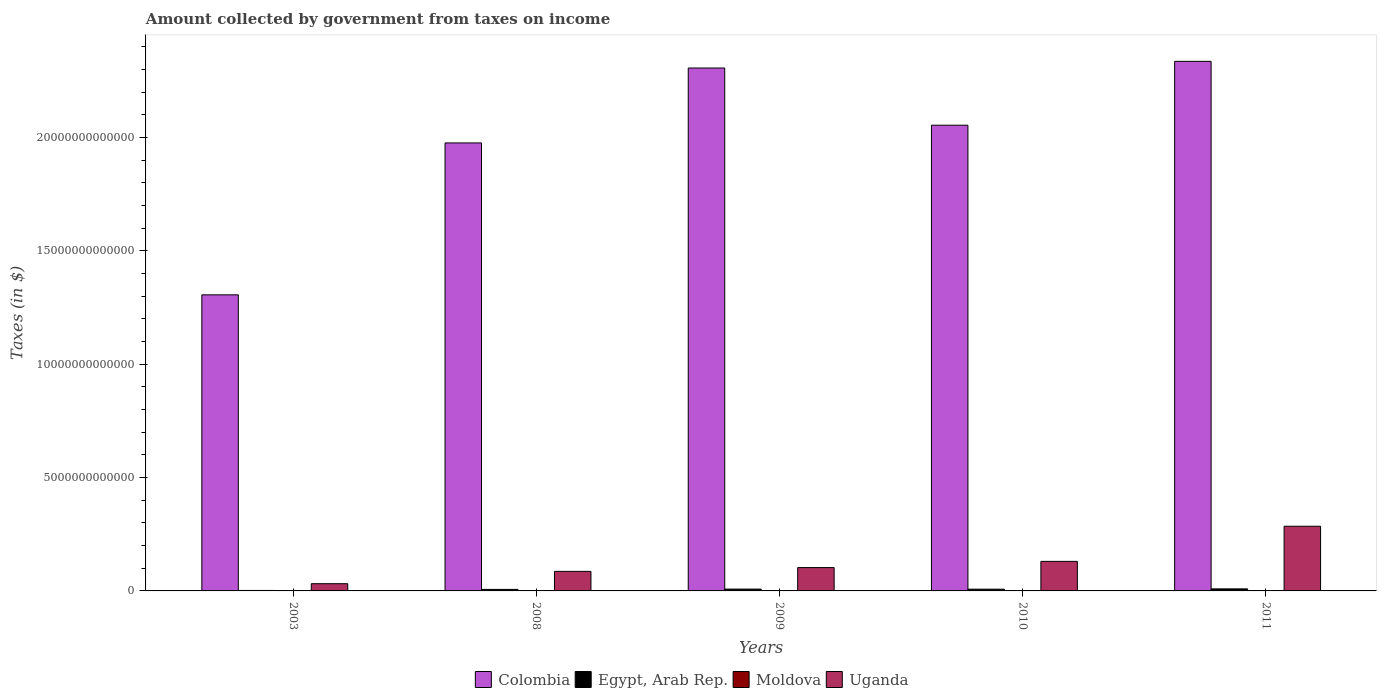How many groups of bars are there?
Offer a very short reply. 5. Are the number of bars per tick equal to the number of legend labels?
Offer a very short reply. Yes. Are the number of bars on each tick of the X-axis equal?
Provide a succinct answer. Yes. How many bars are there on the 5th tick from the left?
Your answer should be very brief. 4. How many bars are there on the 4th tick from the right?
Ensure brevity in your answer.  4. What is the label of the 3rd group of bars from the left?
Offer a very short reply. 2009. In how many cases, is the number of bars for a given year not equal to the number of legend labels?
Offer a terse response. 0. What is the amount collected by government from taxes on income in Moldova in 2009?
Make the answer very short. 1.83e+08. Across all years, what is the maximum amount collected by government from taxes on income in Uganda?
Give a very brief answer. 2.85e+12. Across all years, what is the minimum amount collected by government from taxes on income in Moldova?
Your answer should be compact. 1.83e+08. In which year was the amount collected by government from taxes on income in Egypt, Arab Rep. minimum?
Keep it short and to the point. 2003. What is the total amount collected by government from taxes on income in Moldova in the graph?
Offer a terse response. 1.17e+09. What is the difference between the amount collected by government from taxes on income in Egypt, Arab Rep. in 2003 and that in 2011?
Make the answer very short. -6.88e+1. What is the difference between the amount collected by government from taxes on income in Moldova in 2010 and the amount collected by government from taxes on income in Colombia in 2009?
Make the answer very short. -2.31e+13. What is the average amount collected by government from taxes on income in Moldova per year?
Offer a very short reply. 2.34e+08. In the year 2011, what is the difference between the amount collected by government from taxes on income in Uganda and amount collected by government from taxes on income in Moldova?
Make the answer very short. 2.85e+12. What is the ratio of the amount collected by government from taxes on income in Uganda in 2008 to that in 2009?
Your answer should be compact. 0.84. Is the amount collected by government from taxes on income in Uganda in 2008 less than that in 2009?
Ensure brevity in your answer.  Yes. Is the difference between the amount collected by government from taxes on income in Uganda in 2003 and 2011 greater than the difference between the amount collected by government from taxes on income in Moldova in 2003 and 2011?
Provide a succinct answer. No. What is the difference between the highest and the second highest amount collected by government from taxes on income in Egypt, Arab Rep.?
Offer a terse response. 9.34e+09. What is the difference between the highest and the lowest amount collected by government from taxes on income in Moldova?
Provide a succinct answer. 1.20e+08. What does the 3rd bar from the right in 2011 represents?
Ensure brevity in your answer.  Egypt, Arab Rep. Is it the case that in every year, the sum of the amount collected by government from taxes on income in Egypt, Arab Rep. and amount collected by government from taxes on income in Colombia is greater than the amount collected by government from taxes on income in Uganda?
Ensure brevity in your answer.  Yes. How many bars are there?
Offer a very short reply. 20. Are all the bars in the graph horizontal?
Give a very brief answer. No. What is the difference between two consecutive major ticks on the Y-axis?
Offer a very short reply. 5.00e+12. Are the values on the major ticks of Y-axis written in scientific E-notation?
Ensure brevity in your answer.  No. Does the graph contain any zero values?
Your response must be concise. No. Where does the legend appear in the graph?
Make the answer very short. Bottom center. How many legend labels are there?
Give a very brief answer. 4. How are the legend labels stacked?
Provide a succinct answer. Horizontal. What is the title of the graph?
Provide a short and direct response. Amount collected by government from taxes on income. What is the label or title of the Y-axis?
Give a very brief answer. Taxes (in $). What is the Taxes (in $) in Colombia in 2003?
Make the answer very short. 1.31e+13. What is the Taxes (in $) in Egypt, Arab Rep. in 2003?
Make the answer very short. 2.08e+1. What is the Taxes (in $) of Moldova in 2003?
Your answer should be compact. 2.12e+08. What is the Taxes (in $) of Uganda in 2003?
Your answer should be compact. 3.19e+11. What is the Taxes (in $) in Colombia in 2008?
Keep it short and to the point. 1.98e+13. What is the Taxes (in $) in Egypt, Arab Rep. in 2008?
Make the answer very short. 6.71e+1. What is the Taxes (in $) of Moldova in 2008?
Provide a succinct answer. 3.03e+08. What is the Taxes (in $) in Uganda in 2008?
Your answer should be compact. 8.62e+11. What is the Taxes (in $) in Colombia in 2009?
Ensure brevity in your answer.  2.31e+13. What is the Taxes (in $) in Egypt, Arab Rep. in 2009?
Provide a short and direct response. 8.03e+1. What is the Taxes (in $) of Moldova in 2009?
Keep it short and to the point. 1.83e+08. What is the Taxes (in $) in Uganda in 2009?
Offer a very short reply. 1.03e+12. What is the Taxes (in $) in Colombia in 2010?
Your answer should be very brief. 2.05e+13. What is the Taxes (in $) in Egypt, Arab Rep. in 2010?
Offer a terse response. 7.66e+1. What is the Taxes (in $) in Moldova in 2010?
Provide a short and direct response. 2.16e+08. What is the Taxes (in $) in Uganda in 2010?
Ensure brevity in your answer.  1.30e+12. What is the Taxes (in $) in Colombia in 2011?
Your answer should be compact. 2.34e+13. What is the Taxes (in $) of Egypt, Arab Rep. in 2011?
Keep it short and to the point. 8.96e+1. What is the Taxes (in $) in Moldova in 2011?
Ensure brevity in your answer.  2.58e+08. What is the Taxes (in $) in Uganda in 2011?
Keep it short and to the point. 2.85e+12. Across all years, what is the maximum Taxes (in $) in Colombia?
Ensure brevity in your answer.  2.34e+13. Across all years, what is the maximum Taxes (in $) of Egypt, Arab Rep.?
Ensure brevity in your answer.  8.96e+1. Across all years, what is the maximum Taxes (in $) in Moldova?
Your answer should be very brief. 3.03e+08. Across all years, what is the maximum Taxes (in $) of Uganda?
Your answer should be very brief. 2.85e+12. Across all years, what is the minimum Taxes (in $) of Colombia?
Your response must be concise. 1.31e+13. Across all years, what is the minimum Taxes (in $) of Egypt, Arab Rep.?
Give a very brief answer. 2.08e+1. Across all years, what is the minimum Taxes (in $) in Moldova?
Offer a terse response. 1.83e+08. Across all years, what is the minimum Taxes (in $) of Uganda?
Your answer should be very brief. 3.19e+11. What is the total Taxes (in $) in Colombia in the graph?
Your answer should be very brief. 9.98e+13. What is the total Taxes (in $) of Egypt, Arab Rep. in the graph?
Ensure brevity in your answer.  3.34e+11. What is the total Taxes (in $) of Moldova in the graph?
Offer a terse response. 1.17e+09. What is the total Taxes (in $) in Uganda in the graph?
Ensure brevity in your answer.  6.37e+12. What is the difference between the Taxes (in $) in Colombia in 2003 and that in 2008?
Your answer should be very brief. -6.70e+12. What is the difference between the Taxes (in $) of Egypt, Arab Rep. in 2003 and that in 2008?
Your answer should be compact. -4.62e+1. What is the difference between the Taxes (in $) in Moldova in 2003 and that in 2008?
Keep it short and to the point. -9.14e+07. What is the difference between the Taxes (in $) in Uganda in 2003 and that in 2008?
Offer a terse response. -5.43e+11. What is the difference between the Taxes (in $) of Colombia in 2003 and that in 2009?
Your response must be concise. -1.00e+13. What is the difference between the Taxes (in $) in Egypt, Arab Rep. in 2003 and that in 2009?
Keep it short and to the point. -5.94e+1. What is the difference between the Taxes (in $) of Moldova in 2003 and that in 2009?
Your response must be concise. 2.87e+07. What is the difference between the Taxes (in $) in Uganda in 2003 and that in 2009?
Offer a very short reply. -7.10e+11. What is the difference between the Taxes (in $) in Colombia in 2003 and that in 2010?
Keep it short and to the point. -7.48e+12. What is the difference between the Taxes (in $) in Egypt, Arab Rep. in 2003 and that in 2010?
Offer a terse response. -5.58e+1. What is the difference between the Taxes (in $) of Moldova in 2003 and that in 2010?
Offer a terse response. -3.80e+06. What is the difference between the Taxes (in $) of Uganda in 2003 and that in 2010?
Offer a terse response. -9.84e+11. What is the difference between the Taxes (in $) of Colombia in 2003 and that in 2011?
Offer a very short reply. -1.03e+13. What is the difference between the Taxes (in $) of Egypt, Arab Rep. in 2003 and that in 2011?
Offer a terse response. -6.88e+1. What is the difference between the Taxes (in $) of Moldova in 2003 and that in 2011?
Provide a short and direct response. -4.66e+07. What is the difference between the Taxes (in $) in Uganda in 2003 and that in 2011?
Give a very brief answer. -2.53e+12. What is the difference between the Taxes (in $) of Colombia in 2008 and that in 2009?
Your answer should be compact. -3.30e+12. What is the difference between the Taxes (in $) in Egypt, Arab Rep. in 2008 and that in 2009?
Your answer should be very brief. -1.32e+1. What is the difference between the Taxes (in $) in Moldova in 2008 and that in 2009?
Your response must be concise. 1.20e+08. What is the difference between the Taxes (in $) of Uganda in 2008 and that in 2009?
Your answer should be compact. -1.67e+11. What is the difference between the Taxes (in $) in Colombia in 2008 and that in 2010?
Your response must be concise. -7.82e+11. What is the difference between the Taxes (in $) in Egypt, Arab Rep. in 2008 and that in 2010?
Provide a succinct answer. -9.56e+09. What is the difference between the Taxes (in $) in Moldova in 2008 and that in 2010?
Provide a succinct answer. 8.76e+07. What is the difference between the Taxes (in $) of Uganda in 2008 and that in 2010?
Make the answer very short. -4.41e+11. What is the difference between the Taxes (in $) of Colombia in 2008 and that in 2011?
Offer a very short reply. -3.60e+12. What is the difference between the Taxes (in $) of Egypt, Arab Rep. in 2008 and that in 2011?
Your answer should be compact. -2.25e+1. What is the difference between the Taxes (in $) in Moldova in 2008 and that in 2011?
Ensure brevity in your answer.  4.48e+07. What is the difference between the Taxes (in $) of Uganda in 2008 and that in 2011?
Your response must be concise. -1.99e+12. What is the difference between the Taxes (in $) in Colombia in 2009 and that in 2010?
Your answer should be compact. 2.52e+12. What is the difference between the Taxes (in $) in Egypt, Arab Rep. in 2009 and that in 2010?
Your response must be concise. 3.64e+09. What is the difference between the Taxes (in $) of Moldova in 2009 and that in 2010?
Provide a succinct answer. -3.25e+07. What is the difference between the Taxes (in $) of Uganda in 2009 and that in 2010?
Make the answer very short. -2.74e+11. What is the difference between the Taxes (in $) of Colombia in 2009 and that in 2011?
Your answer should be compact. -2.94e+11. What is the difference between the Taxes (in $) of Egypt, Arab Rep. in 2009 and that in 2011?
Give a very brief answer. -9.34e+09. What is the difference between the Taxes (in $) of Moldova in 2009 and that in 2011?
Offer a terse response. -7.53e+07. What is the difference between the Taxes (in $) in Uganda in 2009 and that in 2011?
Ensure brevity in your answer.  -1.82e+12. What is the difference between the Taxes (in $) in Colombia in 2010 and that in 2011?
Offer a terse response. -2.82e+12. What is the difference between the Taxes (in $) of Egypt, Arab Rep. in 2010 and that in 2011?
Offer a terse response. -1.30e+1. What is the difference between the Taxes (in $) in Moldova in 2010 and that in 2011?
Provide a succinct answer. -4.28e+07. What is the difference between the Taxes (in $) of Uganda in 2010 and that in 2011?
Give a very brief answer. -1.55e+12. What is the difference between the Taxes (in $) of Colombia in 2003 and the Taxes (in $) of Egypt, Arab Rep. in 2008?
Ensure brevity in your answer.  1.30e+13. What is the difference between the Taxes (in $) in Colombia in 2003 and the Taxes (in $) in Moldova in 2008?
Keep it short and to the point. 1.31e+13. What is the difference between the Taxes (in $) of Colombia in 2003 and the Taxes (in $) of Uganda in 2008?
Offer a terse response. 1.22e+13. What is the difference between the Taxes (in $) in Egypt, Arab Rep. in 2003 and the Taxes (in $) in Moldova in 2008?
Ensure brevity in your answer.  2.05e+1. What is the difference between the Taxes (in $) of Egypt, Arab Rep. in 2003 and the Taxes (in $) of Uganda in 2008?
Offer a very short reply. -8.41e+11. What is the difference between the Taxes (in $) of Moldova in 2003 and the Taxes (in $) of Uganda in 2008?
Give a very brief answer. -8.62e+11. What is the difference between the Taxes (in $) of Colombia in 2003 and the Taxes (in $) of Egypt, Arab Rep. in 2009?
Ensure brevity in your answer.  1.30e+13. What is the difference between the Taxes (in $) in Colombia in 2003 and the Taxes (in $) in Moldova in 2009?
Provide a succinct answer. 1.31e+13. What is the difference between the Taxes (in $) of Colombia in 2003 and the Taxes (in $) of Uganda in 2009?
Give a very brief answer. 1.20e+13. What is the difference between the Taxes (in $) of Egypt, Arab Rep. in 2003 and the Taxes (in $) of Moldova in 2009?
Keep it short and to the point. 2.07e+1. What is the difference between the Taxes (in $) of Egypt, Arab Rep. in 2003 and the Taxes (in $) of Uganda in 2009?
Give a very brief answer. -1.01e+12. What is the difference between the Taxes (in $) in Moldova in 2003 and the Taxes (in $) in Uganda in 2009?
Your answer should be very brief. -1.03e+12. What is the difference between the Taxes (in $) of Colombia in 2003 and the Taxes (in $) of Egypt, Arab Rep. in 2010?
Give a very brief answer. 1.30e+13. What is the difference between the Taxes (in $) of Colombia in 2003 and the Taxes (in $) of Moldova in 2010?
Keep it short and to the point. 1.31e+13. What is the difference between the Taxes (in $) of Colombia in 2003 and the Taxes (in $) of Uganda in 2010?
Provide a succinct answer. 1.18e+13. What is the difference between the Taxes (in $) of Egypt, Arab Rep. in 2003 and the Taxes (in $) of Moldova in 2010?
Give a very brief answer. 2.06e+1. What is the difference between the Taxes (in $) of Egypt, Arab Rep. in 2003 and the Taxes (in $) of Uganda in 2010?
Give a very brief answer. -1.28e+12. What is the difference between the Taxes (in $) of Moldova in 2003 and the Taxes (in $) of Uganda in 2010?
Keep it short and to the point. -1.30e+12. What is the difference between the Taxes (in $) in Colombia in 2003 and the Taxes (in $) in Egypt, Arab Rep. in 2011?
Offer a terse response. 1.30e+13. What is the difference between the Taxes (in $) of Colombia in 2003 and the Taxes (in $) of Moldova in 2011?
Your answer should be very brief. 1.31e+13. What is the difference between the Taxes (in $) of Colombia in 2003 and the Taxes (in $) of Uganda in 2011?
Your answer should be very brief. 1.02e+13. What is the difference between the Taxes (in $) in Egypt, Arab Rep. in 2003 and the Taxes (in $) in Moldova in 2011?
Your answer should be very brief. 2.06e+1. What is the difference between the Taxes (in $) of Egypt, Arab Rep. in 2003 and the Taxes (in $) of Uganda in 2011?
Offer a terse response. -2.83e+12. What is the difference between the Taxes (in $) of Moldova in 2003 and the Taxes (in $) of Uganda in 2011?
Make the answer very short. -2.85e+12. What is the difference between the Taxes (in $) of Colombia in 2008 and the Taxes (in $) of Egypt, Arab Rep. in 2009?
Keep it short and to the point. 1.97e+13. What is the difference between the Taxes (in $) of Colombia in 2008 and the Taxes (in $) of Moldova in 2009?
Your answer should be compact. 1.98e+13. What is the difference between the Taxes (in $) in Colombia in 2008 and the Taxes (in $) in Uganda in 2009?
Your answer should be very brief. 1.87e+13. What is the difference between the Taxes (in $) in Egypt, Arab Rep. in 2008 and the Taxes (in $) in Moldova in 2009?
Offer a terse response. 6.69e+1. What is the difference between the Taxes (in $) of Egypt, Arab Rep. in 2008 and the Taxes (in $) of Uganda in 2009?
Provide a short and direct response. -9.62e+11. What is the difference between the Taxes (in $) in Moldova in 2008 and the Taxes (in $) in Uganda in 2009?
Ensure brevity in your answer.  -1.03e+12. What is the difference between the Taxes (in $) in Colombia in 2008 and the Taxes (in $) in Egypt, Arab Rep. in 2010?
Ensure brevity in your answer.  1.97e+13. What is the difference between the Taxes (in $) of Colombia in 2008 and the Taxes (in $) of Moldova in 2010?
Offer a terse response. 1.98e+13. What is the difference between the Taxes (in $) of Colombia in 2008 and the Taxes (in $) of Uganda in 2010?
Make the answer very short. 1.85e+13. What is the difference between the Taxes (in $) in Egypt, Arab Rep. in 2008 and the Taxes (in $) in Moldova in 2010?
Offer a very short reply. 6.68e+1. What is the difference between the Taxes (in $) of Egypt, Arab Rep. in 2008 and the Taxes (in $) of Uganda in 2010?
Provide a succinct answer. -1.24e+12. What is the difference between the Taxes (in $) of Moldova in 2008 and the Taxes (in $) of Uganda in 2010?
Your response must be concise. -1.30e+12. What is the difference between the Taxes (in $) of Colombia in 2008 and the Taxes (in $) of Egypt, Arab Rep. in 2011?
Provide a succinct answer. 1.97e+13. What is the difference between the Taxes (in $) of Colombia in 2008 and the Taxes (in $) of Moldova in 2011?
Provide a succinct answer. 1.98e+13. What is the difference between the Taxes (in $) of Colombia in 2008 and the Taxes (in $) of Uganda in 2011?
Make the answer very short. 1.69e+13. What is the difference between the Taxes (in $) in Egypt, Arab Rep. in 2008 and the Taxes (in $) in Moldova in 2011?
Provide a succinct answer. 6.68e+1. What is the difference between the Taxes (in $) of Egypt, Arab Rep. in 2008 and the Taxes (in $) of Uganda in 2011?
Provide a short and direct response. -2.79e+12. What is the difference between the Taxes (in $) of Moldova in 2008 and the Taxes (in $) of Uganda in 2011?
Your answer should be compact. -2.85e+12. What is the difference between the Taxes (in $) of Colombia in 2009 and the Taxes (in $) of Egypt, Arab Rep. in 2010?
Keep it short and to the point. 2.30e+13. What is the difference between the Taxes (in $) in Colombia in 2009 and the Taxes (in $) in Moldova in 2010?
Offer a terse response. 2.31e+13. What is the difference between the Taxes (in $) of Colombia in 2009 and the Taxes (in $) of Uganda in 2010?
Make the answer very short. 2.18e+13. What is the difference between the Taxes (in $) in Egypt, Arab Rep. in 2009 and the Taxes (in $) in Moldova in 2010?
Keep it short and to the point. 8.00e+1. What is the difference between the Taxes (in $) in Egypt, Arab Rep. in 2009 and the Taxes (in $) in Uganda in 2010?
Offer a terse response. -1.22e+12. What is the difference between the Taxes (in $) of Moldova in 2009 and the Taxes (in $) of Uganda in 2010?
Provide a short and direct response. -1.30e+12. What is the difference between the Taxes (in $) in Colombia in 2009 and the Taxes (in $) in Egypt, Arab Rep. in 2011?
Offer a very short reply. 2.30e+13. What is the difference between the Taxes (in $) of Colombia in 2009 and the Taxes (in $) of Moldova in 2011?
Your answer should be very brief. 2.31e+13. What is the difference between the Taxes (in $) of Colombia in 2009 and the Taxes (in $) of Uganda in 2011?
Keep it short and to the point. 2.02e+13. What is the difference between the Taxes (in $) of Egypt, Arab Rep. in 2009 and the Taxes (in $) of Moldova in 2011?
Give a very brief answer. 8.00e+1. What is the difference between the Taxes (in $) in Egypt, Arab Rep. in 2009 and the Taxes (in $) in Uganda in 2011?
Offer a very short reply. -2.77e+12. What is the difference between the Taxes (in $) of Moldova in 2009 and the Taxes (in $) of Uganda in 2011?
Make the answer very short. -2.85e+12. What is the difference between the Taxes (in $) in Colombia in 2010 and the Taxes (in $) in Egypt, Arab Rep. in 2011?
Your response must be concise. 2.04e+13. What is the difference between the Taxes (in $) in Colombia in 2010 and the Taxes (in $) in Moldova in 2011?
Your response must be concise. 2.05e+13. What is the difference between the Taxes (in $) in Colombia in 2010 and the Taxes (in $) in Uganda in 2011?
Provide a short and direct response. 1.77e+13. What is the difference between the Taxes (in $) of Egypt, Arab Rep. in 2010 and the Taxes (in $) of Moldova in 2011?
Provide a short and direct response. 7.64e+1. What is the difference between the Taxes (in $) in Egypt, Arab Rep. in 2010 and the Taxes (in $) in Uganda in 2011?
Offer a terse response. -2.78e+12. What is the difference between the Taxes (in $) of Moldova in 2010 and the Taxes (in $) of Uganda in 2011?
Make the answer very short. -2.85e+12. What is the average Taxes (in $) of Colombia per year?
Your response must be concise. 2.00e+13. What is the average Taxes (in $) of Egypt, Arab Rep. per year?
Provide a succinct answer. 6.69e+1. What is the average Taxes (in $) of Moldova per year?
Your answer should be very brief. 2.34e+08. What is the average Taxes (in $) of Uganda per year?
Keep it short and to the point. 1.27e+12. In the year 2003, what is the difference between the Taxes (in $) in Colombia and Taxes (in $) in Egypt, Arab Rep.?
Your response must be concise. 1.30e+13. In the year 2003, what is the difference between the Taxes (in $) in Colombia and Taxes (in $) in Moldova?
Offer a terse response. 1.31e+13. In the year 2003, what is the difference between the Taxes (in $) in Colombia and Taxes (in $) in Uganda?
Offer a very short reply. 1.27e+13. In the year 2003, what is the difference between the Taxes (in $) of Egypt, Arab Rep. and Taxes (in $) of Moldova?
Offer a very short reply. 2.06e+1. In the year 2003, what is the difference between the Taxes (in $) in Egypt, Arab Rep. and Taxes (in $) in Uganda?
Make the answer very short. -2.98e+11. In the year 2003, what is the difference between the Taxes (in $) in Moldova and Taxes (in $) in Uganda?
Keep it short and to the point. -3.19e+11. In the year 2008, what is the difference between the Taxes (in $) of Colombia and Taxes (in $) of Egypt, Arab Rep.?
Your answer should be very brief. 1.97e+13. In the year 2008, what is the difference between the Taxes (in $) in Colombia and Taxes (in $) in Moldova?
Your response must be concise. 1.98e+13. In the year 2008, what is the difference between the Taxes (in $) of Colombia and Taxes (in $) of Uganda?
Offer a terse response. 1.89e+13. In the year 2008, what is the difference between the Taxes (in $) in Egypt, Arab Rep. and Taxes (in $) in Moldova?
Keep it short and to the point. 6.68e+1. In the year 2008, what is the difference between the Taxes (in $) in Egypt, Arab Rep. and Taxes (in $) in Uganda?
Your response must be concise. -7.95e+11. In the year 2008, what is the difference between the Taxes (in $) in Moldova and Taxes (in $) in Uganda?
Provide a succinct answer. -8.62e+11. In the year 2009, what is the difference between the Taxes (in $) of Colombia and Taxes (in $) of Egypt, Arab Rep.?
Provide a short and direct response. 2.30e+13. In the year 2009, what is the difference between the Taxes (in $) of Colombia and Taxes (in $) of Moldova?
Offer a very short reply. 2.31e+13. In the year 2009, what is the difference between the Taxes (in $) of Colombia and Taxes (in $) of Uganda?
Offer a terse response. 2.20e+13. In the year 2009, what is the difference between the Taxes (in $) of Egypt, Arab Rep. and Taxes (in $) of Moldova?
Provide a short and direct response. 8.01e+1. In the year 2009, what is the difference between the Taxes (in $) in Egypt, Arab Rep. and Taxes (in $) in Uganda?
Your answer should be very brief. -9.49e+11. In the year 2009, what is the difference between the Taxes (in $) in Moldova and Taxes (in $) in Uganda?
Ensure brevity in your answer.  -1.03e+12. In the year 2010, what is the difference between the Taxes (in $) in Colombia and Taxes (in $) in Egypt, Arab Rep.?
Provide a succinct answer. 2.05e+13. In the year 2010, what is the difference between the Taxes (in $) of Colombia and Taxes (in $) of Moldova?
Offer a very short reply. 2.05e+13. In the year 2010, what is the difference between the Taxes (in $) of Colombia and Taxes (in $) of Uganda?
Give a very brief answer. 1.92e+13. In the year 2010, what is the difference between the Taxes (in $) in Egypt, Arab Rep. and Taxes (in $) in Moldova?
Keep it short and to the point. 7.64e+1. In the year 2010, what is the difference between the Taxes (in $) of Egypt, Arab Rep. and Taxes (in $) of Uganda?
Ensure brevity in your answer.  -1.23e+12. In the year 2010, what is the difference between the Taxes (in $) of Moldova and Taxes (in $) of Uganda?
Ensure brevity in your answer.  -1.30e+12. In the year 2011, what is the difference between the Taxes (in $) in Colombia and Taxes (in $) in Egypt, Arab Rep.?
Ensure brevity in your answer.  2.33e+13. In the year 2011, what is the difference between the Taxes (in $) of Colombia and Taxes (in $) of Moldova?
Your response must be concise. 2.34e+13. In the year 2011, what is the difference between the Taxes (in $) in Colombia and Taxes (in $) in Uganda?
Keep it short and to the point. 2.05e+13. In the year 2011, what is the difference between the Taxes (in $) in Egypt, Arab Rep. and Taxes (in $) in Moldova?
Offer a terse response. 8.93e+1. In the year 2011, what is the difference between the Taxes (in $) of Egypt, Arab Rep. and Taxes (in $) of Uganda?
Offer a terse response. -2.76e+12. In the year 2011, what is the difference between the Taxes (in $) of Moldova and Taxes (in $) of Uganda?
Make the answer very short. -2.85e+12. What is the ratio of the Taxes (in $) in Colombia in 2003 to that in 2008?
Your answer should be very brief. 0.66. What is the ratio of the Taxes (in $) of Egypt, Arab Rep. in 2003 to that in 2008?
Make the answer very short. 0.31. What is the ratio of the Taxes (in $) in Moldova in 2003 to that in 2008?
Offer a very short reply. 0.7. What is the ratio of the Taxes (in $) of Uganda in 2003 to that in 2008?
Make the answer very short. 0.37. What is the ratio of the Taxes (in $) of Colombia in 2003 to that in 2009?
Offer a very short reply. 0.57. What is the ratio of the Taxes (in $) of Egypt, Arab Rep. in 2003 to that in 2009?
Your answer should be compact. 0.26. What is the ratio of the Taxes (in $) in Moldova in 2003 to that in 2009?
Provide a succinct answer. 1.16. What is the ratio of the Taxes (in $) in Uganda in 2003 to that in 2009?
Keep it short and to the point. 0.31. What is the ratio of the Taxes (in $) of Colombia in 2003 to that in 2010?
Your answer should be compact. 0.64. What is the ratio of the Taxes (in $) of Egypt, Arab Rep. in 2003 to that in 2010?
Keep it short and to the point. 0.27. What is the ratio of the Taxes (in $) of Moldova in 2003 to that in 2010?
Give a very brief answer. 0.98. What is the ratio of the Taxes (in $) in Uganda in 2003 to that in 2010?
Your response must be concise. 0.24. What is the ratio of the Taxes (in $) in Colombia in 2003 to that in 2011?
Provide a short and direct response. 0.56. What is the ratio of the Taxes (in $) in Egypt, Arab Rep. in 2003 to that in 2011?
Provide a short and direct response. 0.23. What is the ratio of the Taxes (in $) of Moldova in 2003 to that in 2011?
Offer a very short reply. 0.82. What is the ratio of the Taxes (in $) of Uganda in 2003 to that in 2011?
Ensure brevity in your answer.  0.11. What is the ratio of the Taxes (in $) of Colombia in 2008 to that in 2009?
Provide a short and direct response. 0.86. What is the ratio of the Taxes (in $) in Egypt, Arab Rep. in 2008 to that in 2009?
Your response must be concise. 0.84. What is the ratio of the Taxes (in $) of Moldova in 2008 to that in 2009?
Give a very brief answer. 1.66. What is the ratio of the Taxes (in $) of Uganda in 2008 to that in 2009?
Your answer should be very brief. 0.84. What is the ratio of the Taxes (in $) of Colombia in 2008 to that in 2010?
Provide a succinct answer. 0.96. What is the ratio of the Taxes (in $) in Egypt, Arab Rep. in 2008 to that in 2010?
Your response must be concise. 0.88. What is the ratio of the Taxes (in $) in Moldova in 2008 to that in 2010?
Provide a succinct answer. 1.41. What is the ratio of the Taxes (in $) of Uganda in 2008 to that in 2010?
Ensure brevity in your answer.  0.66. What is the ratio of the Taxes (in $) in Colombia in 2008 to that in 2011?
Make the answer very short. 0.85. What is the ratio of the Taxes (in $) in Egypt, Arab Rep. in 2008 to that in 2011?
Give a very brief answer. 0.75. What is the ratio of the Taxes (in $) in Moldova in 2008 to that in 2011?
Ensure brevity in your answer.  1.17. What is the ratio of the Taxes (in $) in Uganda in 2008 to that in 2011?
Your answer should be compact. 0.3. What is the ratio of the Taxes (in $) of Colombia in 2009 to that in 2010?
Make the answer very short. 1.12. What is the ratio of the Taxes (in $) of Egypt, Arab Rep. in 2009 to that in 2010?
Your answer should be very brief. 1.05. What is the ratio of the Taxes (in $) in Moldova in 2009 to that in 2010?
Your answer should be compact. 0.85. What is the ratio of the Taxes (in $) of Uganda in 2009 to that in 2010?
Your answer should be compact. 0.79. What is the ratio of the Taxes (in $) in Colombia in 2009 to that in 2011?
Give a very brief answer. 0.99. What is the ratio of the Taxes (in $) in Egypt, Arab Rep. in 2009 to that in 2011?
Your answer should be very brief. 0.9. What is the ratio of the Taxes (in $) of Moldova in 2009 to that in 2011?
Your answer should be very brief. 0.71. What is the ratio of the Taxes (in $) of Uganda in 2009 to that in 2011?
Give a very brief answer. 0.36. What is the ratio of the Taxes (in $) of Colombia in 2010 to that in 2011?
Keep it short and to the point. 0.88. What is the ratio of the Taxes (in $) in Egypt, Arab Rep. in 2010 to that in 2011?
Your response must be concise. 0.86. What is the ratio of the Taxes (in $) in Moldova in 2010 to that in 2011?
Ensure brevity in your answer.  0.83. What is the ratio of the Taxes (in $) in Uganda in 2010 to that in 2011?
Your response must be concise. 0.46. What is the difference between the highest and the second highest Taxes (in $) in Colombia?
Your answer should be compact. 2.94e+11. What is the difference between the highest and the second highest Taxes (in $) in Egypt, Arab Rep.?
Ensure brevity in your answer.  9.34e+09. What is the difference between the highest and the second highest Taxes (in $) of Moldova?
Your answer should be compact. 4.48e+07. What is the difference between the highest and the second highest Taxes (in $) in Uganda?
Provide a succinct answer. 1.55e+12. What is the difference between the highest and the lowest Taxes (in $) of Colombia?
Keep it short and to the point. 1.03e+13. What is the difference between the highest and the lowest Taxes (in $) of Egypt, Arab Rep.?
Provide a short and direct response. 6.88e+1. What is the difference between the highest and the lowest Taxes (in $) of Moldova?
Offer a terse response. 1.20e+08. What is the difference between the highest and the lowest Taxes (in $) in Uganda?
Make the answer very short. 2.53e+12. 